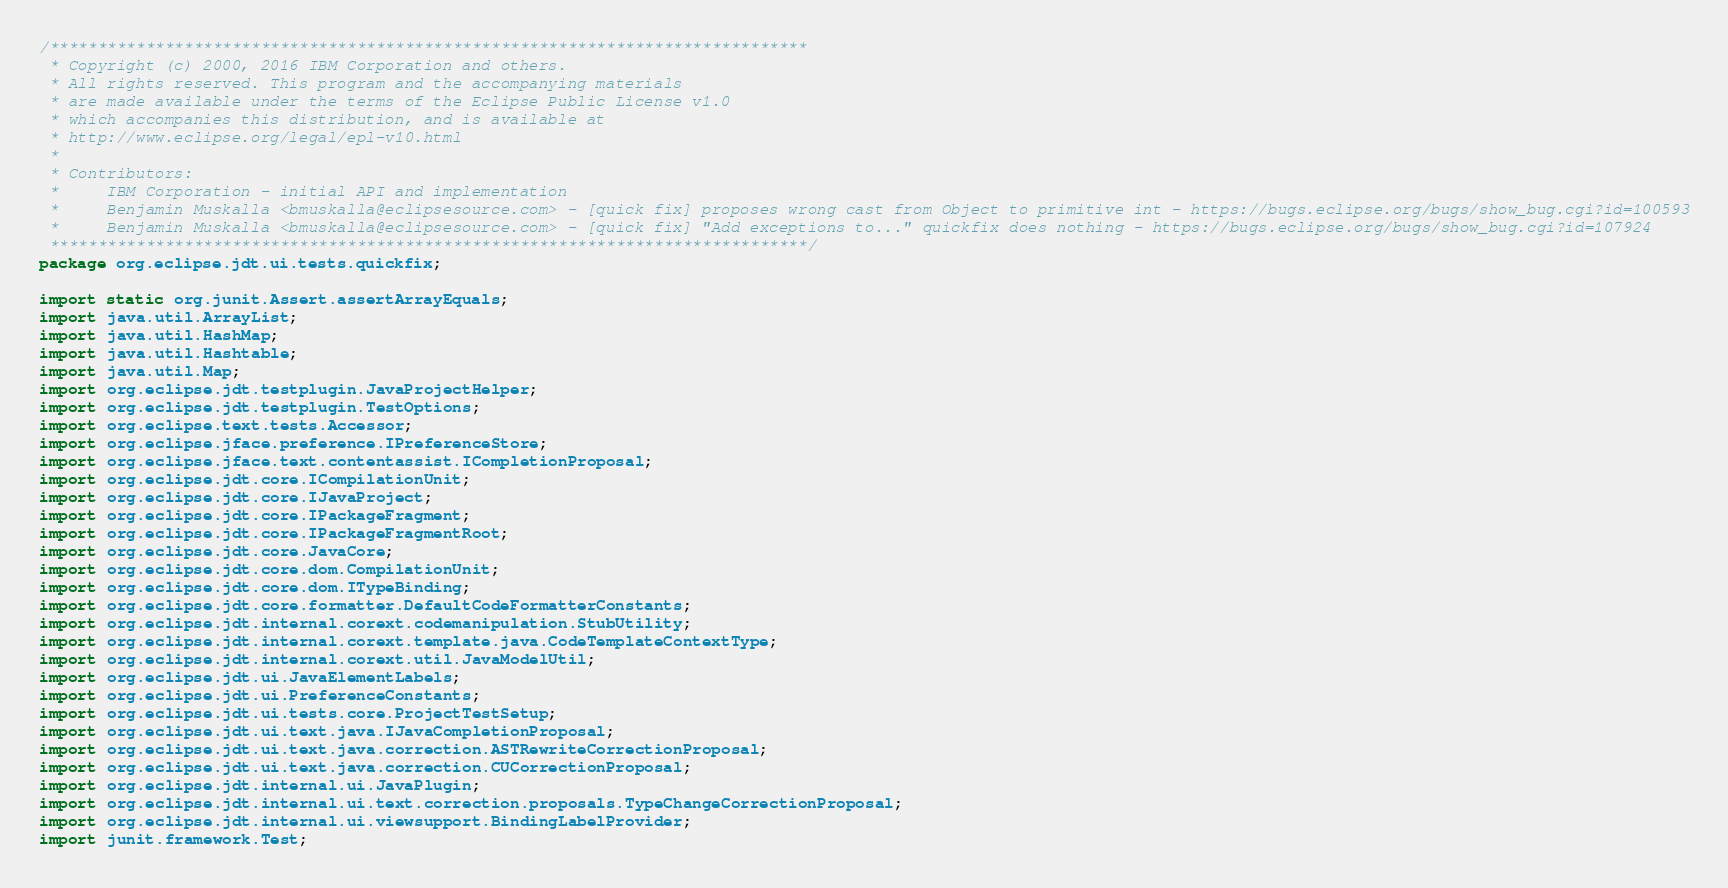<code> <loc_0><loc_0><loc_500><loc_500><_Java_>/*******************************************************************************
 * Copyright (c) 2000, 2016 IBM Corporation and others.
 * All rights reserved. This program and the accompanying materials
 * are made available under the terms of the Eclipse Public License v1.0
 * which accompanies this distribution, and is available at
 * http://www.eclipse.org/legal/epl-v10.html
 *
 * Contributors:
 *     IBM Corporation - initial API and implementation
 *     Benjamin Muskalla <bmuskalla@eclipsesource.com> - [quick fix] proposes wrong cast from Object to primitive int - https://bugs.eclipse.org/bugs/show_bug.cgi?id=100593
 *     Benjamin Muskalla <bmuskalla@eclipsesource.com> - [quick fix] "Add exceptions to..." quickfix does nothing - https://bugs.eclipse.org/bugs/show_bug.cgi?id=107924
 *******************************************************************************/
package org.eclipse.jdt.ui.tests.quickfix;

import static org.junit.Assert.assertArrayEquals;
import java.util.ArrayList;
import java.util.HashMap;
import java.util.Hashtable;
import java.util.Map;
import org.eclipse.jdt.testplugin.JavaProjectHelper;
import org.eclipse.jdt.testplugin.TestOptions;
import org.eclipse.text.tests.Accessor;
import org.eclipse.jface.preference.IPreferenceStore;
import org.eclipse.jface.text.contentassist.ICompletionProposal;
import org.eclipse.jdt.core.ICompilationUnit;
import org.eclipse.jdt.core.IJavaProject;
import org.eclipse.jdt.core.IPackageFragment;
import org.eclipse.jdt.core.IPackageFragmentRoot;
import org.eclipse.jdt.core.JavaCore;
import org.eclipse.jdt.core.dom.CompilationUnit;
import org.eclipse.jdt.core.dom.ITypeBinding;
import org.eclipse.jdt.core.formatter.DefaultCodeFormatterConstants;
import org.eclipse.jdt.internal.corext.codemanipulation.StubUtility;
import org.eclipse.jdt.internal.corext.template.java.CodeTemplateContextType;
import org.eclipse.jdt.internal.corext.util.JavaModelUtil;
import org.eclipse.jdt.ui.JavaElementLabels;
import org.eclipse.jdt.ui.PreferenceConstants;
import org.eclipse.jdt.ui.tests.core.ProjectTestSetup;
import org.eclipse.jdt.ui.text.java.IJavaCompletionProposal;
import org.eclipse.jdt.ui.text.java.correction.ASTRewriteCorrectionProposal;
import org.eclipse.jdt.ui.text.java.correction.CUCorrectionProposal;
import org.eclipse.jdt.internal.ui.JavaPlugin;
import org.eclipse.jdt.internal.ui.text.correction.proposals.TypeChangeCorrectionProposal;
import org.eclipse.jdt.internal.ui.viewsupport.BindingLabelProvider;
import junit.framework.Test;</code> 